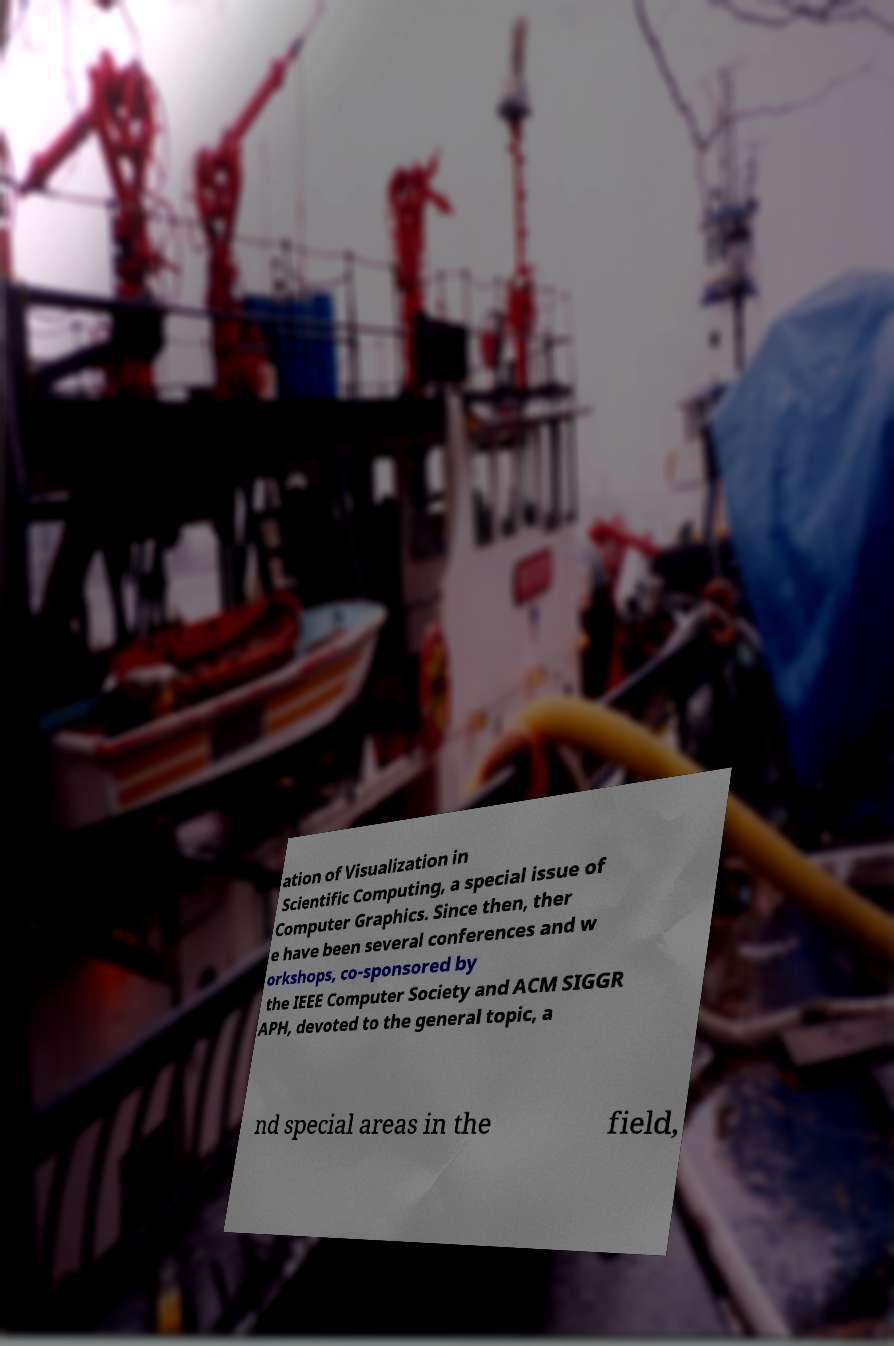Please read and relay the text visible in this image. What does it say? ation of Visualization in Scientific Computing, a special issue of Computer Graphics. Since then, ther e have been several conferences and w orkshops, co-sponsored by the IEEE Computer Society and ACM SIGGR APH, devoted to the general topic, a nd special areas in the field, 